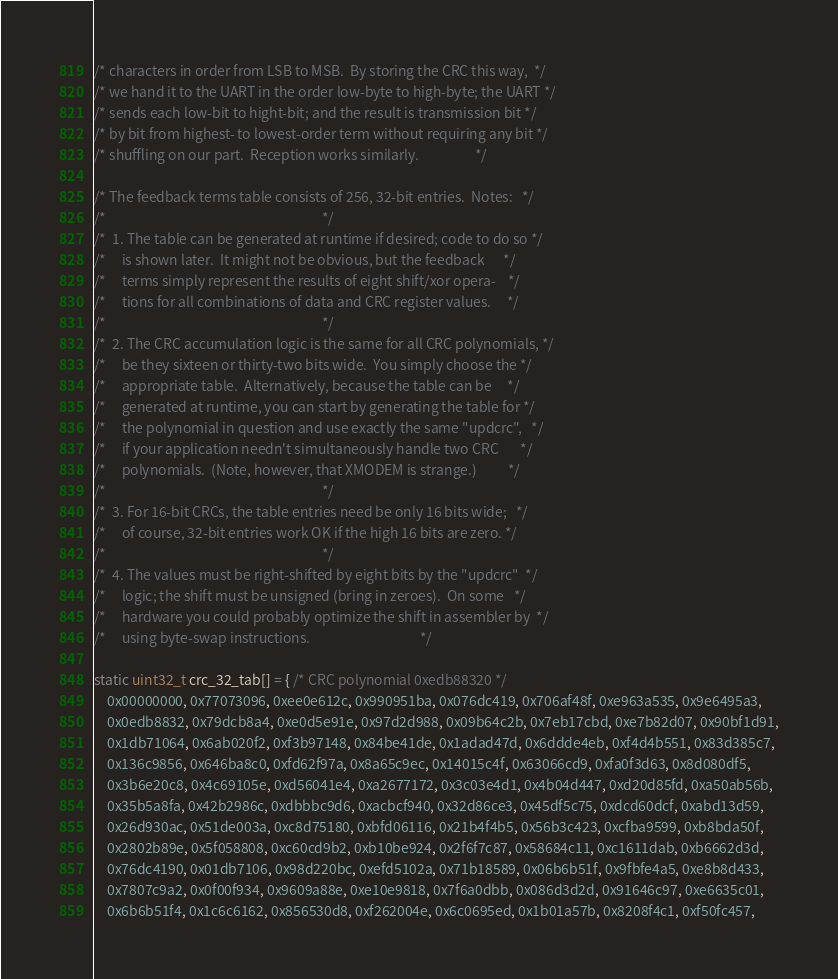<code> <loc_0><loc_0><loc_500><loc_500><_C++_>/* characters in order from LSB to MSB.  By storing the CRC this way,  */
/* we hand it to the UART in the order low-byte to high-byte; the UART */
/* sends each low-bit to hight-bit; and the result is transmission bit */
/* by bit from highest- to lowest-order term without requiring any bit */
/* shuffling on our part.  Reception works similarly.                  */

/* The feedback terms table consists of 256, 32-bit entries.  Notes:   */
/*                                                                     */
/*  1. The table can be generated at runtime if desired; code to do so */
/*     is shown later.  It might not be obvious, but the feedback      */
/*     terms simply represent the results of eight shift/xor opera-    */
/*     tions for all combinations of data and CRC register values.     */
/*                                                                     */
/*  2. The CRC accumulation logic is the same for all CRC polynomials, */
/*     be they sixteen or thirty-two bits wide.  You simply choose the */
/*     appropriate table.  Alternatively, because the table can be     */
/*     generated at runtime, you can start by generating the table for */
/*     the polynomial in question and use exactly the same "updcrc",   */
/*     if your application needn't simultaneously handle two CRC       */
/*     polynomials.  (Note, however, that XMODEM is strange.)          */
/*                                                                     */
/*  3. For 16-bit CRCs, the table entries need be only 16 bits wide;   */
/*     of course, 32-bit entries work OK if the high 16 bits are zero. */
/*                                                                     */
/*  4. The values must be right-shifted by eight bits by the "updcrc"  */
/*     logic; the shift must be unsigned (bring in zeroes).  On some   */
/*     hardware you could probably optimize the shift in assembler by  */
/*     using byte-swap instructions.                                   */

static uint32_t crc_32_tab[] = { /* CRC polynomial 0xedb88320 */
    0x00000000, 0x77073096, 0xee0e612c, 0x990951ba, 0x076dc419, 0x706af48f, 0xe963a535, 0x9e6495a3,
    0x0edb8832, 0x79dcb8a4, 0xe0d5e91e, 0x97d2d988, 0x09b64c2b, 0x7eb17cbd, 0xe7b82d07, 0x90bf1d91,
    0x1db71064, 0x6ab020f2, 0xf3b97148, 0x84be41de, 0x1adad47d, 0x6ddde4eb, 0xf4d4b551, 0x83d385c7,
    0x136c9856, 0x646ba8c0, 0xfd62f97a, 0x8a65c9ec, 0x14015c4f, 0x63066cd9, 0xfa0f3d63, 0x8d080df5,
    0x3b6e20c8, 0x4c69105e, 0xd56041e4, 0xa2677172, 0x3c03e4d1, 0x4b04d447, 0xd20d85fd, 0xa50ab56b,
    0x35b5a8fa, 0x42b2986c, 0xdbbbc9d6, 0xacbcf940, 0x32d86ce3, 0x45df5c75, 0xdcd60dcf, 0xabd13d59,
    0x26d930ac, 0x51de003a, 0xc8d75180, 0xbfd06116, 0x21b4f4b5, 0x56b3c423, 0xcfba9599, 0xb8bda50f,
    0x2802b89e, 0x5f058808, 0xc60cd9b2, 0xb10be924, 0x2f6f7c87, 0x58684c11, 0xc1611dab, 0xb6662d3d,
    0x76dc4190, 0x01db7106, 0x98d220bc, 0xefd5102a, 0x71b18589, 0x06b6b51f, 0x9fbfe4a5, 0xe8b8d433,
    0x7807c9a2, 0x0f00f934, 0x9609a88e, 0xe10e9818, 0x7f6a0dbb, 0x086d3d2d, 0x91646c97, 0xe6635c01,
    0x6b6b51f4, 0x1c6c6162, 0x856530d8, 0xf262004e, 0x6c0695ed, 0x1b01a57b, 0x8208f4c1, 0xf50fc457,</code> 